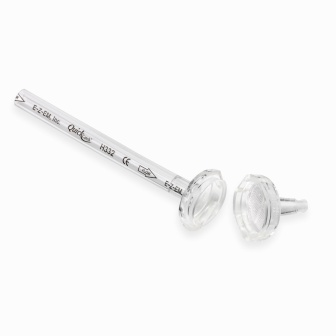Can you describe the object in detail and ponder its possible uses? The image features an exquisitely crafted silver-colored metal rod, adorned with faceted, clear plastic knobs at both ends, lending it a refined and polished appearance. The metal rod is meticulously engraved with the words 'Esker' and 'Pride' on one side, along with 'H42' and 'Esker' on the other, suggesting it might have been crafted with great care and precision. Its composition of materials and design accents hint at potentially diverse uses. It could be an elegant decorative item for modern interiors, a unique tool for scientific purposes, or even a part of a more complex and sophisticated mechanism. This object's cultural or historical background might also be of significance, sparking endless possibilities for its role in art, science, or industry. Where do you think this object originated from? Without definite markers, it's speculative to determine the exact origin of the object. However, given the intricate craftsmanship and the distinct engravings such as 'Esker' and 'Pride,' it could originate from a specialized manufacturer or a niche boutique brand. The detailed markings suggest it could be part of a collection or a limited edition, possibly produced by a company in the high-end home decor or scientific equipment sector. Additionally, 'H42' might be a model number or a reference code unique to its production line. Imagine a whimsical use for this object! Imagine, if you will, this rod being an enchanted scepter from a faraway, mystical kingdom. The clear plastic knobs are actually magical crystals, holding ancient powers of light and wisdom. When wielded by the worthy, it can illuminate the darkest realms and reveal hidden truths. The engravings 'Esker,' 'Pride,' and 'H42' are incantations that unlock portals to other dimensions. In a grand adventure tale, our hero discovers this scepter in a forgotten attic, setting off on an epic quest to restore balance to the world! 